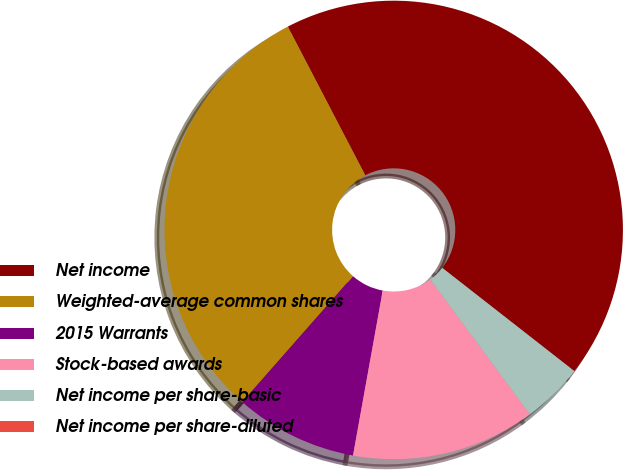Convert chart to OTSL. <chart><loc_0><loc_0><loc_500><loc_500><pie_chart><fcel>Net income<fcel>Weighted-average common shares<fcel>2015 Warrants<fcel>Stock-based awards<fcel>Net income per share-basic<fcel>Net income per share-diluted<nl><fcel>43.2%<fcel>30.88%<fcel>8.64%<fcel>12.96%<fcel>4.32%<fcel>0.0%<nl></chart> 